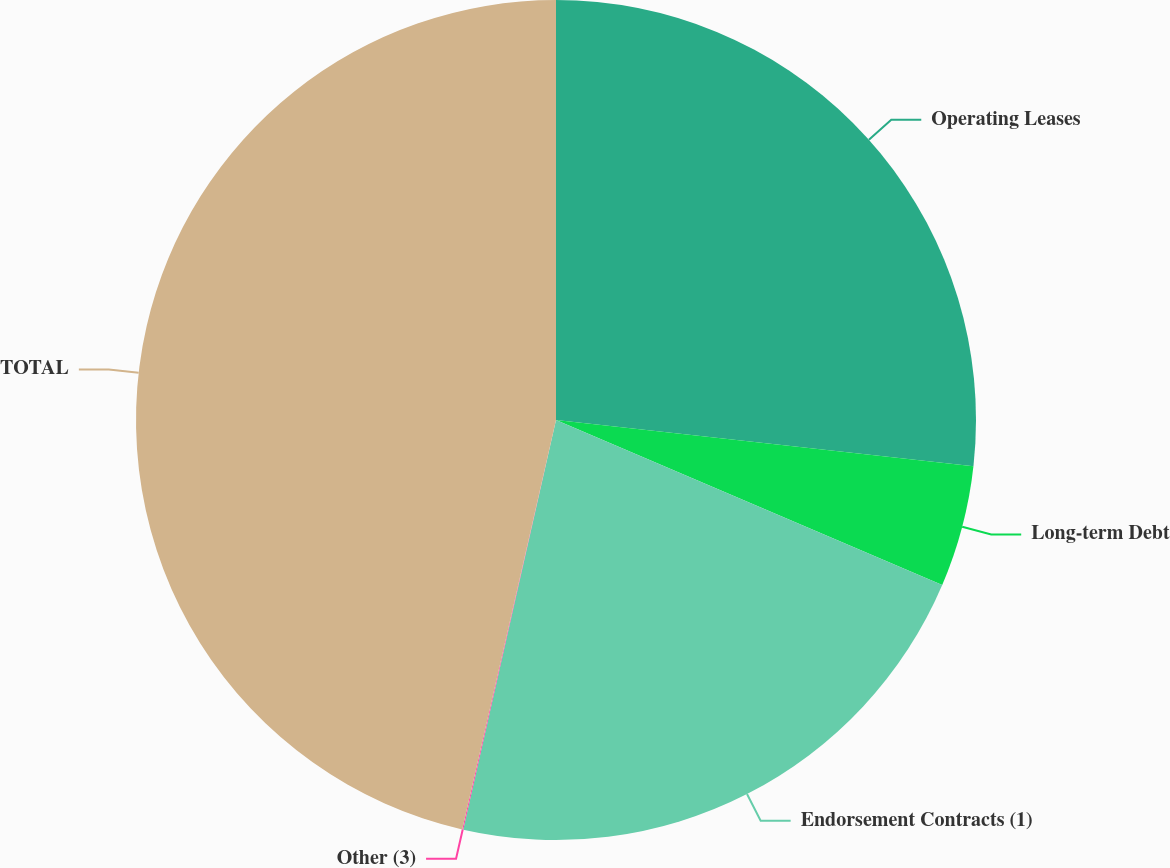Convert chart. <chart><loc_0><loc_0><loc_500><loc_500><pie_chart><fcel>Operating Leases<fcel>Long-term Debt<fcel>Endorsement Contracts (1)<fcel>Other (3)<fcel>TOTAL<nl><fcel>26.76%<fcel>4.67%<fcel>22.12%<fcel>0.04%<fcel>46.42%<nl></chart> 